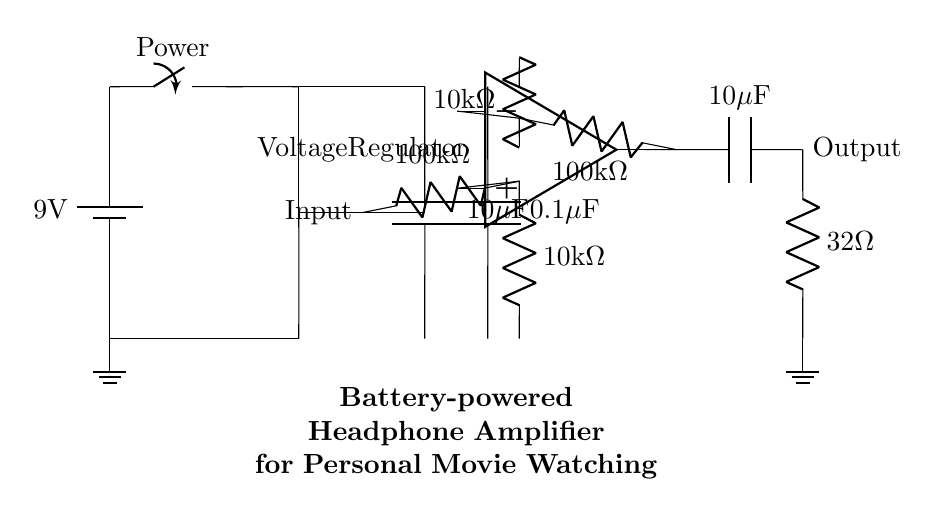What is the input resistance of the amplifier? The input resistance, as shown in the circuit, is represented by the resistor connected at the input node, which is labeled as one hundred thousand ohms.
Answer: one hundred thousand ohms What is the supply voltage for the amplifier? The supply voltage is provided by a battery, which in this circuit is labeled as nine volts.
Answer: nine volts What type of capacitors are used at the output? At the output, there is one capacitor labeled as ten microfarads, which indicates the type is a coupling capacitor for audio signals.
Answer: ten microfarads What is the role of the voltage regulator in this circuit? The voltage regulator is used to maintain a constant supply voltage for the op-amp and other components despite changes in load current or input voltage.
Answer: maintain constant voltage How does the feedback affect the gain of the amplifier? The feedback resistor, connected from the output back to the inverting input of the op-amp, sets the gain. The relationship can be determined from the resistor values in the feedback loop compared to the input resistance.
Answer: sets gain What is the output impedance of the amplifier? The output impedance corresponds to the connected resistor at the output, which is labeled as thirty-two ohms, indicating it is suitable for driving headphones.
Answer: thirty-two ohms 